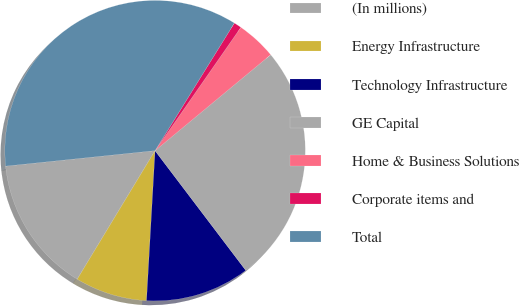<chart> <loc_0><loc_0><loc_500><loc_500><pie_chart><fcel>(In millions)<fcel>Energy Infrastructure<fcel>Technology Infrastructure<fcel>GE Capital<fcel>Home & Business Solutions<fcel>Corporate items and<fcel>Total<nl><fcel>14.69%<fcel>7.76%<fcel>11.23%<fcel>25.7%<fcel>4.3%<fcel>0.83%<fcel>35.49%<nl></chart> 